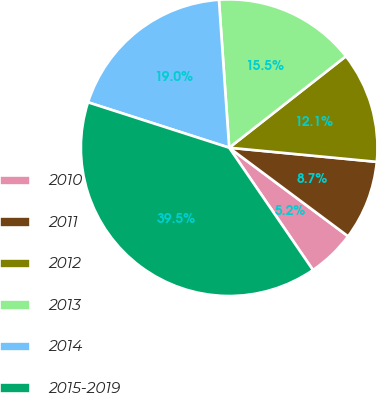<chart> <loc_0><loc_0><loc_500><loc_500><pie_chart><fcel>2010<fcel>2011<fcel>2012<fcel>2013<fcel>2014<fcel>2015-2019<nl><fcel>5.25%<fcel>8.67%<fcel>12.1%<fcel>15.52%<fcel>18.95%<fcel>39.51%<nl></chart> 